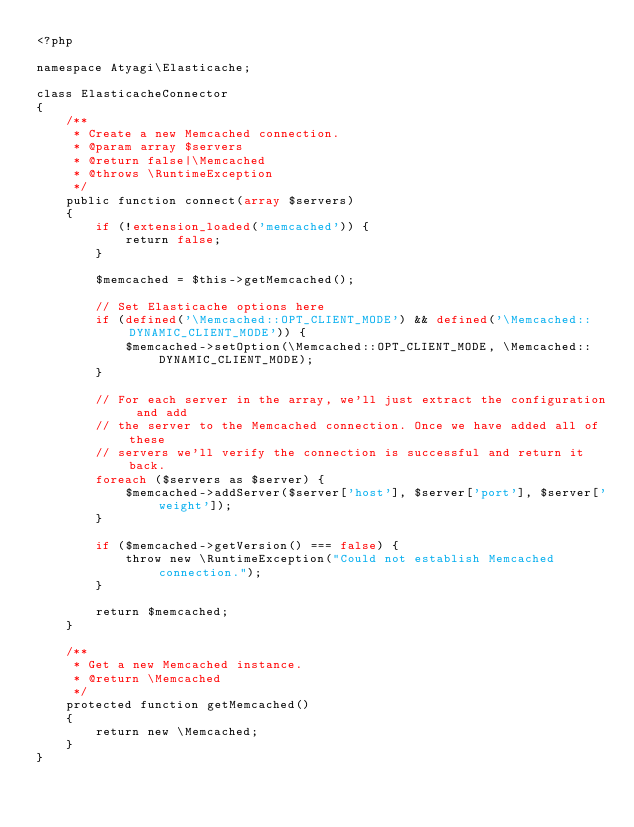Convert code to text. <code><loc_0><loc_0><loc_500><loc_500><_PHP_><?php 

namespace Atyagi\Elasticache;

class ElasticacheConnector
{
    /**
     * Create a new Memcached connection.
     * @param array $servers
     * @return false|\Memcached
     * @throws \RuntimeException
     */
    public function connect(array $servers)
    {
        if (!extension_loaded('memcached')) {
            return false;
        }

        $memcached = $this->getMemcached();

        // Set Elasticache options here
        if (defined('\Memcached::OPT_CLIENT_MODE') && defined('\Memcached::DYNAMIC_CLIENT_MODE')) {
            $memcached->setOption(\Memcached::OPT_CLIENT_MODE, \Memcached::DYNAMIC_CLIENT_MODE);
        }

        // For each server in the array, we'll just extract the configuration and add
        // the server to the Memcached connection. Once we have added all of these
        // servers we'll verify the connection is successful and return it back.
        foreach ($servers as $server) {
            $memcached->addServer($server['host'], $server['port'], $server['weight']);
        }

        if ($memcached->getVersion() === false) {
            throw new \RuntimeException("Could not establish Memcached connection.");
        }

        return $memcached;
    }

    /**
     * Get a new Memcached instance.
     * @return \Memcached
     */
    protected function getMemcached()
    {
        return new \Memcached;
    }
}
</code> 